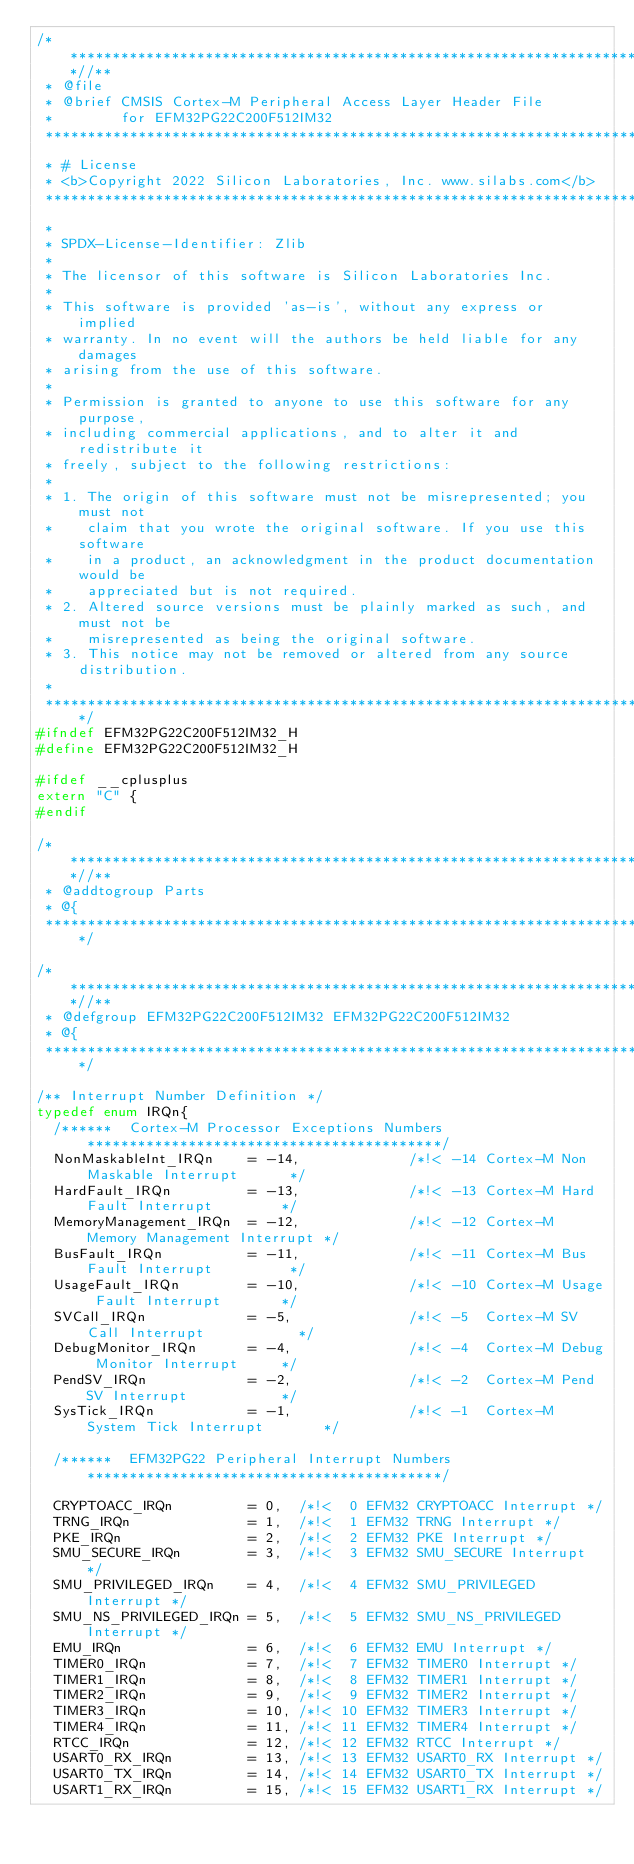Convert code to text. <code><loc_0><loc_0><loc_500><loc_500><_C_>/**************************************************************************//**
 * @file
 * @brief CMSIS Cortex-M Peripheral Access Layer Header File
 *        for EFM32PG22C200F512IM32
 ******************************************************************************
 * # License
 * <b>Copyright 2022 Silicon Laboratories, Inc. www.silabs.com</b>
 ******************************************************************************
 *
 * SPDX-License-Identifier: Zlib
 *
 * The licensor of this software is Silicon Laboratories Inc.
 *
 * This software is provided 'as-is', without any express or implied
 * warranty. In no event will the authors be held liable for any damages
 * arising from the use of this software.
 *
 * Permission is granted to anyone to use this software for any purpose,
 * including commercial applications, and to alter it and redistribute it
 * freely, subject to the following restrictions:
 *
 * 1. The origin of this software must not be misrepresented; you must not
 *    claim that you wrote the original software. If you use this software
 *    in a product, an acknowledgment in the product documentation would be
 *    appreciated but is not required.
 * 2. Altered source versions must be plainly marked as such, and must not be
 *    misrepresented as being the original software.
 * 3. This notice may not be removed or altered from any source distribution.
 *
 *****************************************************************************/
#ifndef EFM32PG22C200F512IM32_H
#define EFM32PG22C200F512IM32_H

#ifdef __cplusplus
extern "C" {
#endif

/**************************************************************************//**
 * @addtogroup Parts
 * @{
 *****************************************************************************/

/**************************************************************************//**
 * @defgroup EFM32PG22C200F512IM32 EFM32PG22C200F512IM32
 * @{
 *****************************************************************************/

/** Interrupt Number Definition */
typedef enum IRQn{
  /******  Cortex-M Processor Exceptions Numbers ******************************************/
  NonMaskableInt_IRQn    = -14,             /*!< -14 Cortex-M Non Maskable Interrupt      */
  HardFault_IRQn         = -13,             /*!< -13 Cortex-M Hard Fault Interrupt        */
  MemoryManagement_IRQn  = -12,             /*!< -12 Cortex-M Memory Management Interrupt */
  BusFault_IRQn          = -11,             /*!< -11 Cortex-M Bus Fault Interrupt         */
  UsageFault_IRQn        = -10,             /*!< -10 Cortex-M Usage Fault Interrupt       */
  SVCall_IRQn            = -5,              /*!< -5  Cortex-M SV Call Interrupt           */
  DebugMonitor_IRQn      = -4,              /*!< -4  Cortex-M Debug Monitor Interrupt     */
  PendSV_IRQn            = -2,              /*!< -2  Cortex-M Pend SV Interrupt           */
  SysTick_IRQn           = -1,              /*!< -1  Cortex-M System Tick Interrupt       */

  /******  EFM32PG22 Peripheral Interrupt Numbers ******************************************/

  CRYPTOACC_IRQn         = 0,  /*!<  0 EFM32 CRYPTOACC Interrupt */
  TRNG_IRQn              = 1,  /*!<  1 EFM32 TRNG Interrupt */
  PKE_IRQn               = 2,  /*!<  2 EFM32 PKE Interrupt */
  SMU_SECURE_IRQn        = 3,  /*!<  3 EFM32 SMU_SECURE Interrupt */
  SMU_PRIVILEGED_IRQn    = 4,  /*!<  4 EFM32 SMU_PRIVILEGED Interrupt */
  SMU_NS_PRIVILEGED_IRQn = 5,  /*!<  5 EFM32 SMU_NS_PRIVILEGED Interrupt */
  EMU_IRQn               = 6,  /*!<  6 EFM32 EMU Interrupt */
  TIMER0_IRQn            = 7,  /*!<  7 EFM32 TIMER0 Interrupt */
  TIMER1_IRQn            = 8,  /*!<  8 EFM32 TIMER1 Interrupt */
  TIMER2_IRQn            = 9,  /*!<  9 EFM32 TIMER2 Interrupt */
  TIMER3_IRQn            = 10, /*!< 10 EFM32 TIMER3 Interrupt */
  TIMER4_IRQn            = 11, /*!< 11 EFM32 TIMER4 Interrupt */
  RTCC_IRQn              = 12, /*!< 12 EFM32 RTCC Interrupt */
  USART0_RX_IRQn         = 13, /*!< 13 EFM32 USART0_RX Interrupt */
  USART0_TX_IRQn         = 14, /*!< 14 EFM32 USART0_TX Interrupt */
  USART1_RX_IRQn         = 15, /*!< 15 EFM32 USART1_RX Interrupt */</code> 